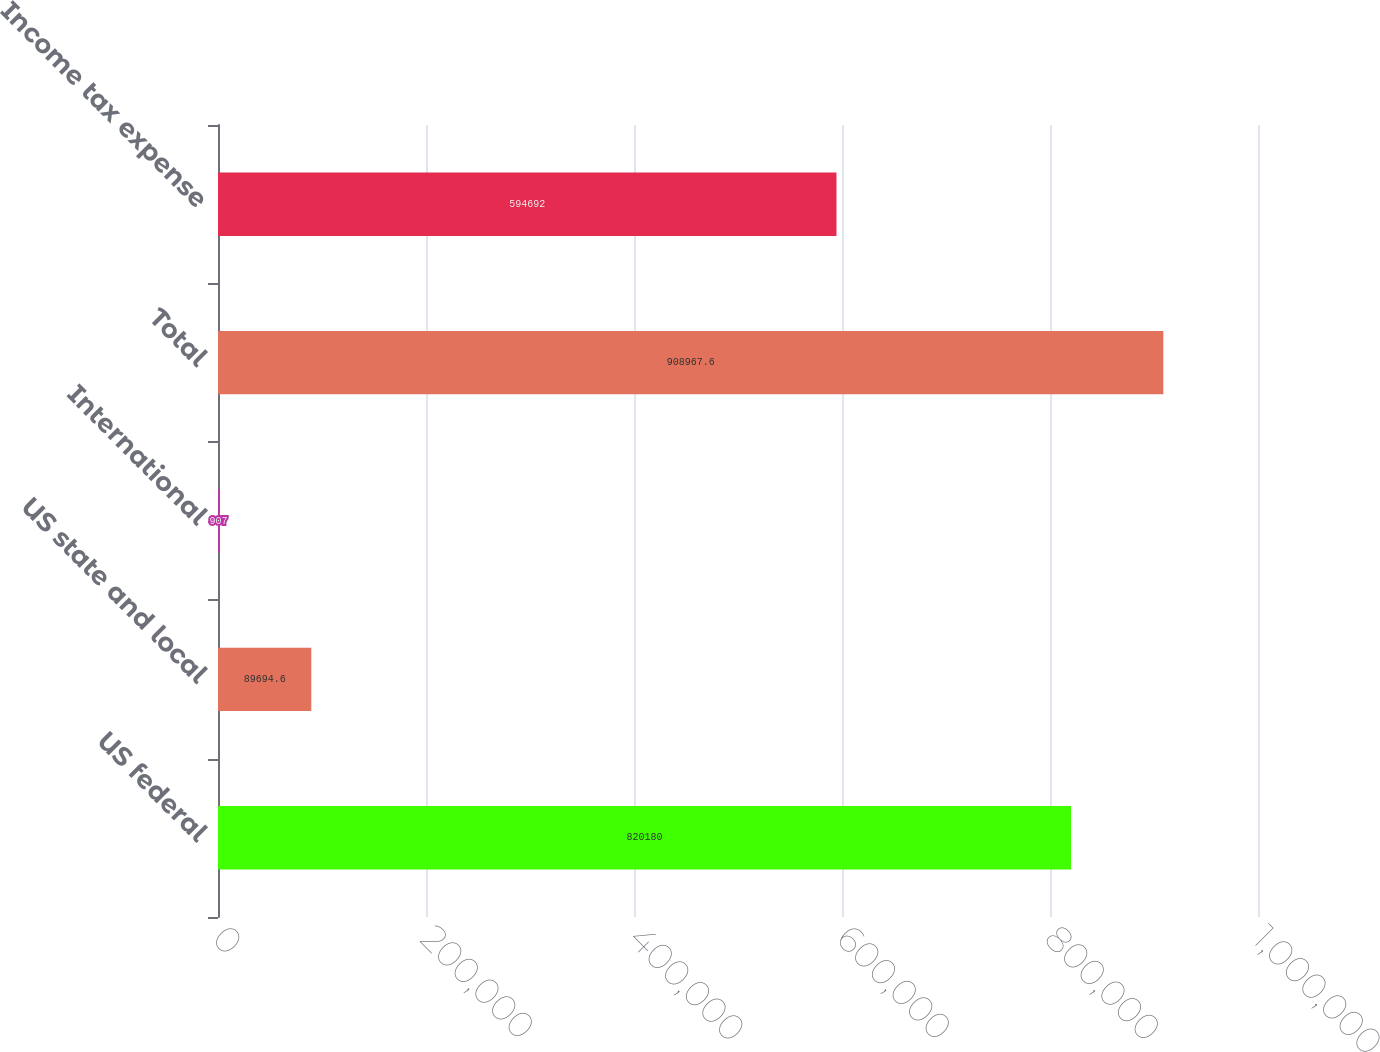Convert chart. <chart><loc_0><loc_0><loc_500><loc_500><bar_chart><fcel>US federal<fcel>US state and local<fcel>International<fcel>Total<fcel>Income tax expense<nl><fcel>820180<fcel>89694.6<fcel>907<fcel>908968<fcel>594692<nl></chart> 